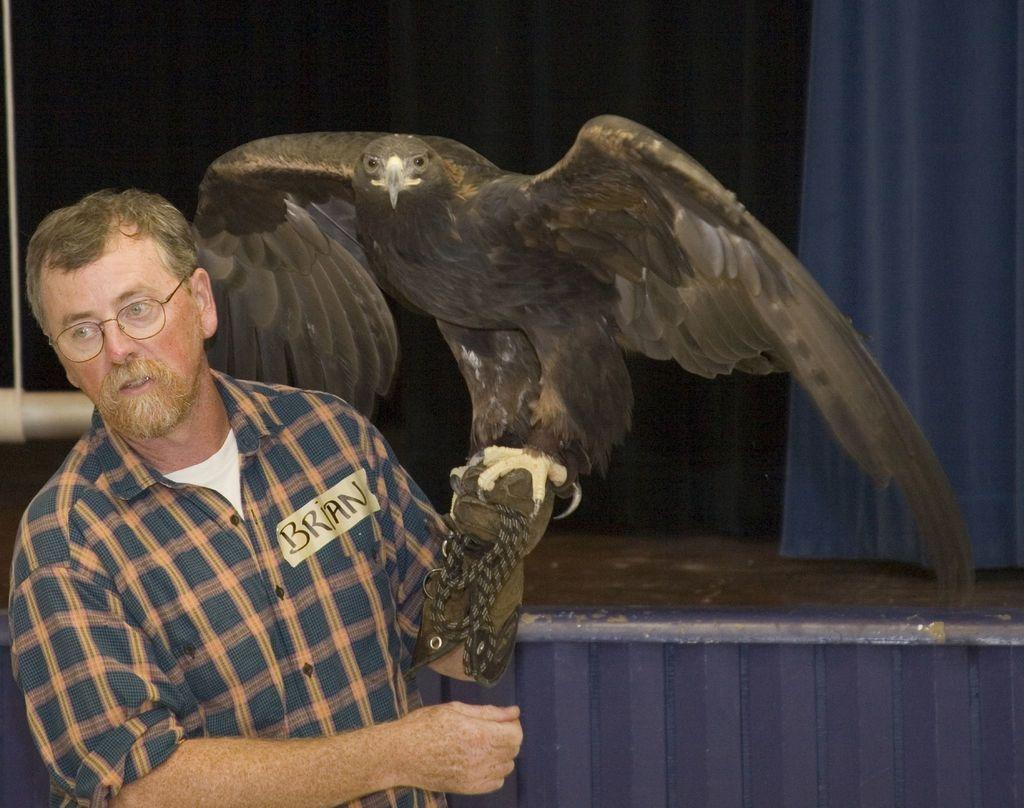Who is the main subject in the image? There is a man standing in the front of the image. What animal can be seen in the image? There is an eagle in the image. What accessory is the man wearing? The man is wearing spectacles. What can be seen in the background of the image? There is a curtain in the background of the image. How many toys are on the floor in the image? There are no toys present in the image. What type of pain is the man experiencing in the image? There is no indication of pain in the image; the man is simply standing. 